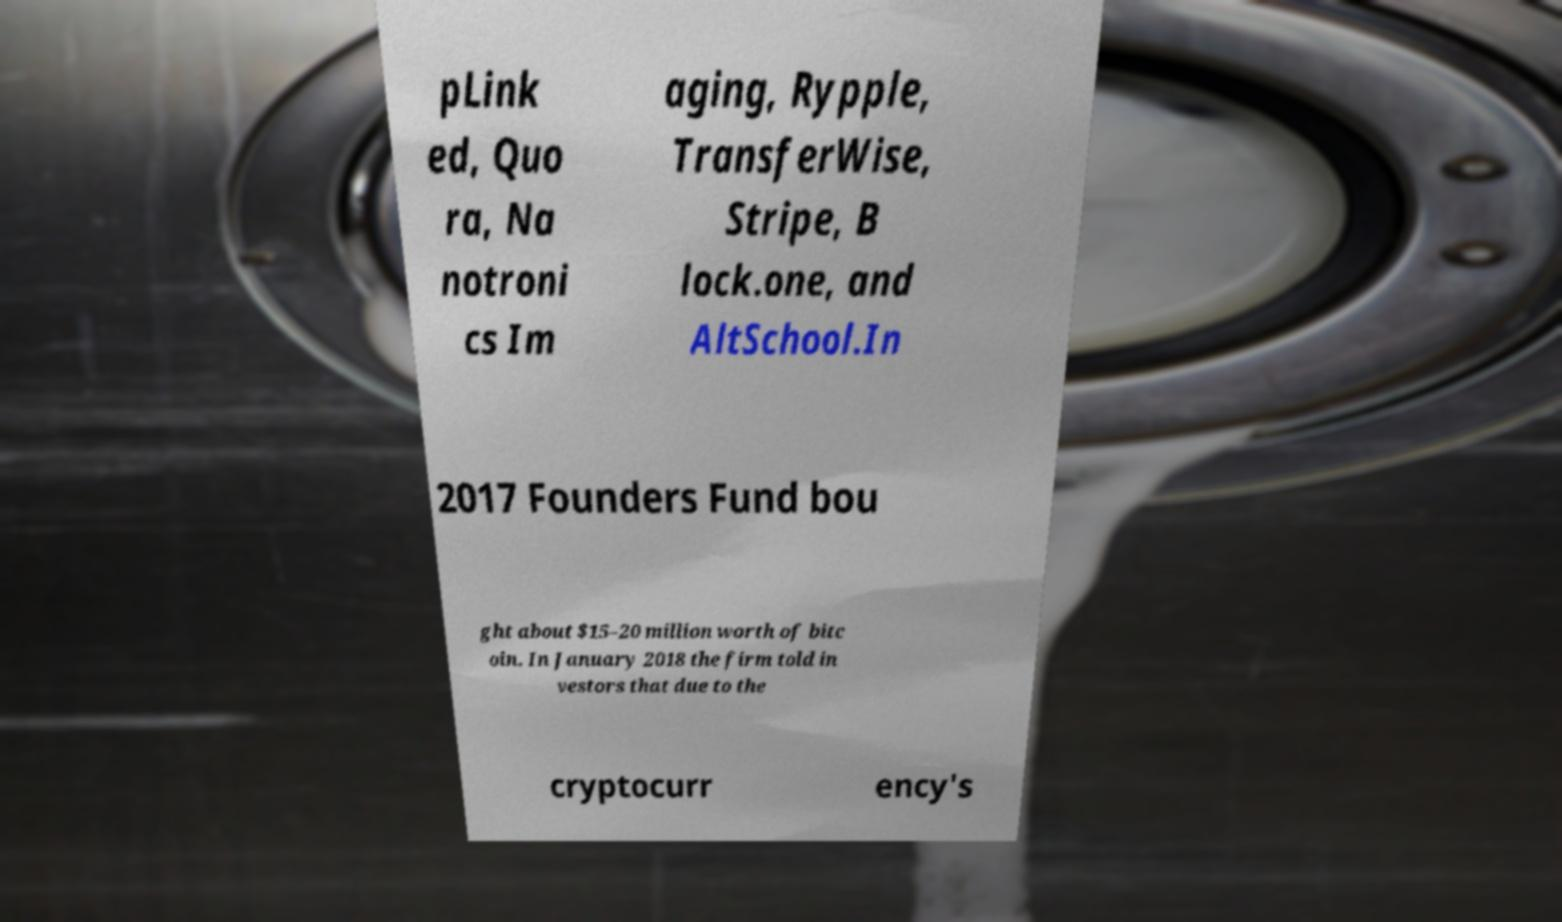Can you accurately transcribe the text from the provided image for me? pLink ed, Quo ra, Na notroni cs Im aging, Rypple, TransferWise, Stripe, B lock.one, and AltSchool.In 2017 Founders Fund bou ght about $15–20 million worth of bitc oin. In January 2018 the firm told in vestors that due to the cryptocurr ency's 